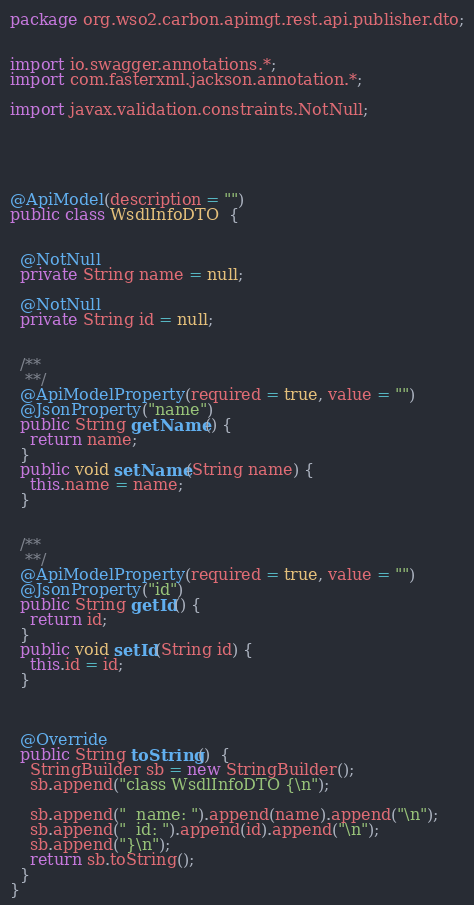Convert code to text. <code><loc_0><loc_0><loc_500><loc_500><_Java_>package org.wso2.carbon.apimgt.rest.api.publisher.dto;


import io.swagger.annotations.*;
import com.fasterxml.jackson.annotation.*;

import javax.validation.constraints.NotNull;





@ApiModel(description = "")
public class WsdlInfoDTO  {
  
  
  @NotNull
  private String name = null;
  
  @NotNull
  private String id = null;

  
  /**
   **/
  @ApiModelProperty(required = true, value = "")
  @JsonProperty("name")
  public String getName() {
    return name;
  }
  public void setName(String name) {
    this.name = name;
  }

  
  /**
   **/
  @ApiModelProperty(required = true, value = "")
  @JsonProperty("id")
  public String getId() {
    return id;
  }
  public void setId(String id) {
    this.id = id;
  }

  

  @Override
  public String toString()  {
    StringBuilder sb = new StringBuilder();
    sb.append("class WsdlInfoDTO {\n");
    
    sb.append("  name: ").append(name).append("\n");
    sb.append("  id: ").append(id).append("\n");
    sb.append("}\n");
    return sb.toString();
  }
}
</code> 